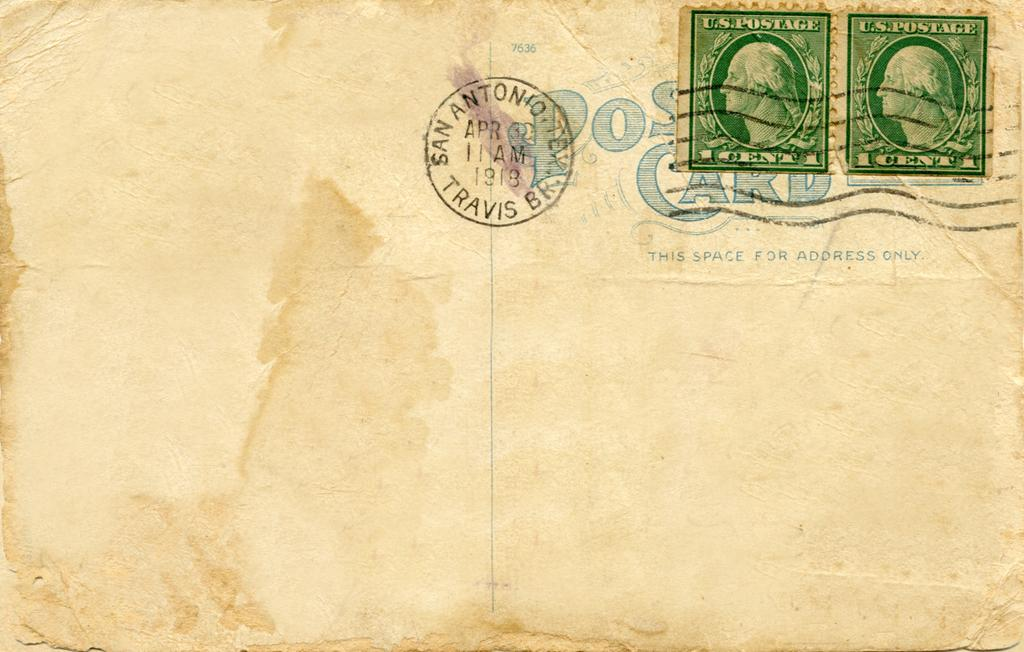What is the main object in the image? There is a postcard in the image. What can be seen on the left side of the postcard? There are stamps and text on the left side of the postcard. What is in the center of the postcard? There is a post emblem in the center of the postcard. What type of needle is used to sing the song on the postcard? There is no needle or song present on the postcard; it only features stamps, text, and a post emblem. 